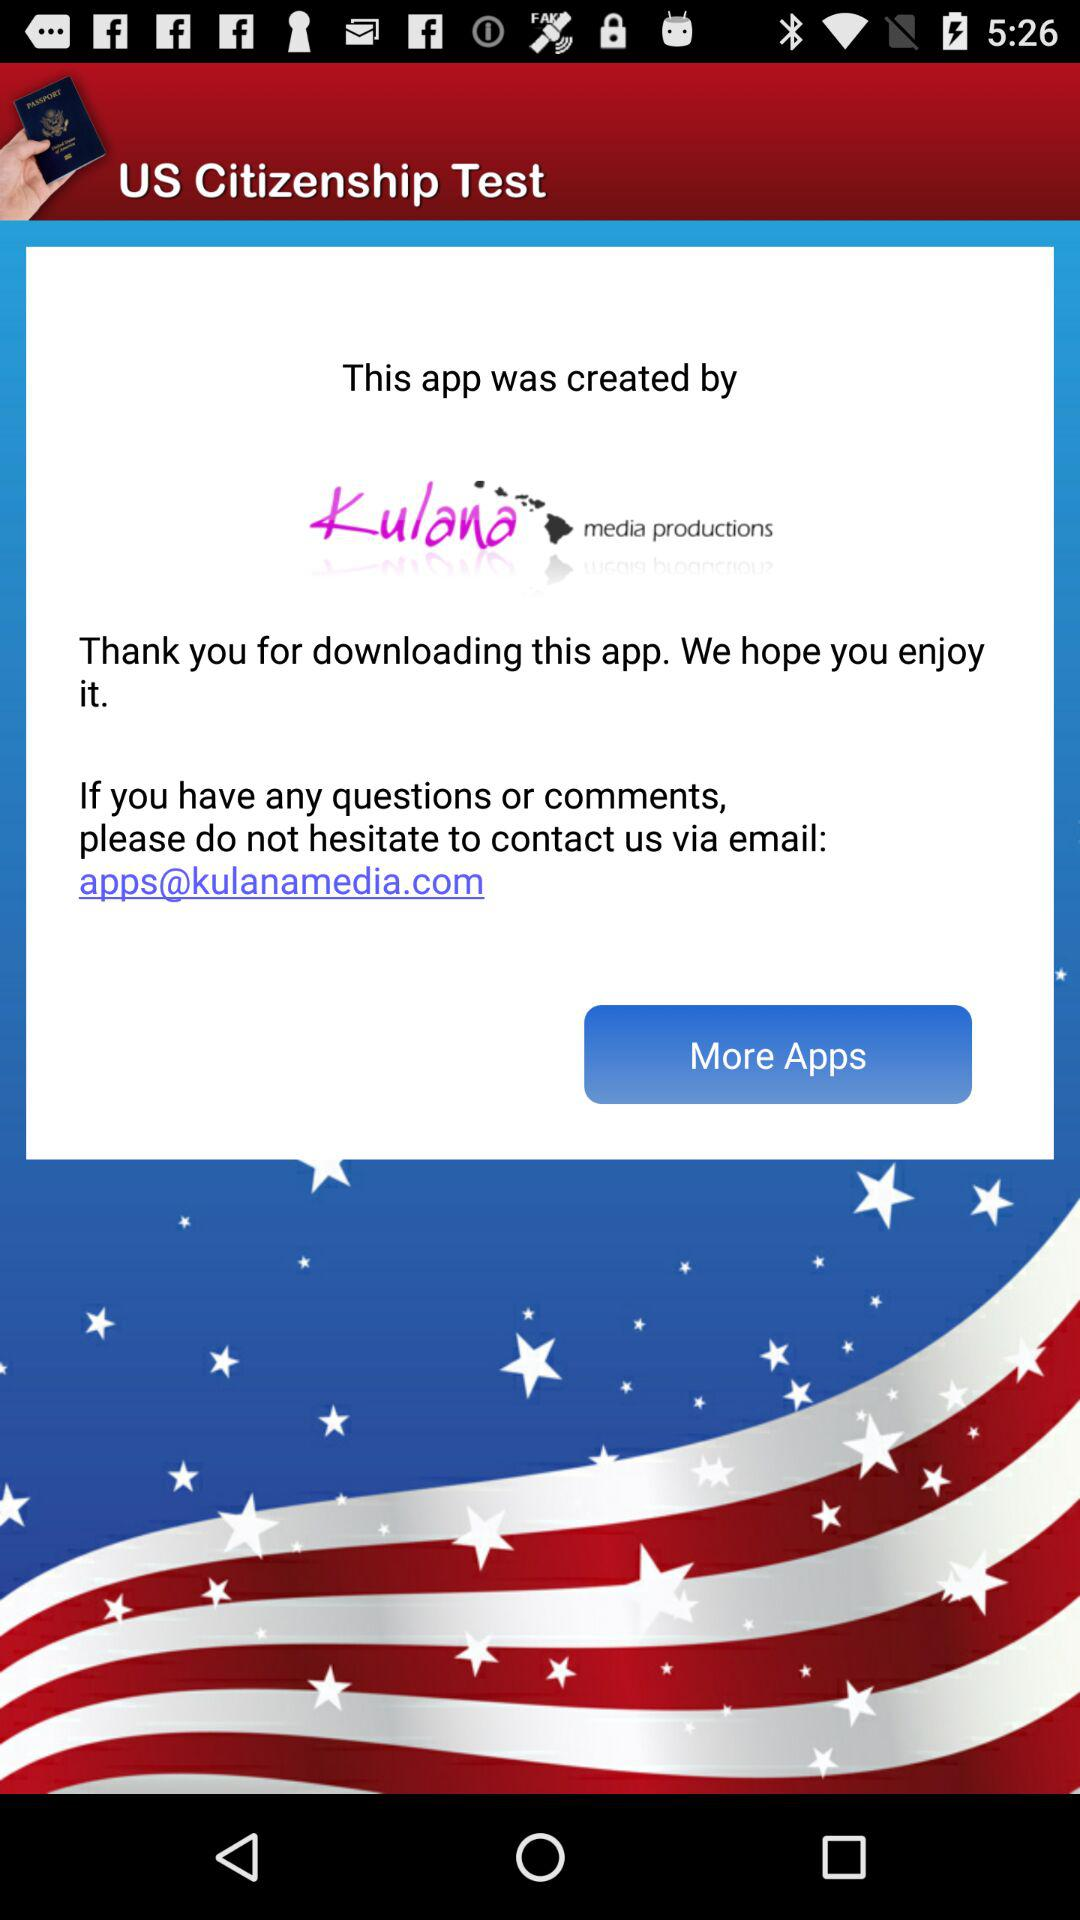What is the email address? The email address is apps@kulanamedia.com. 